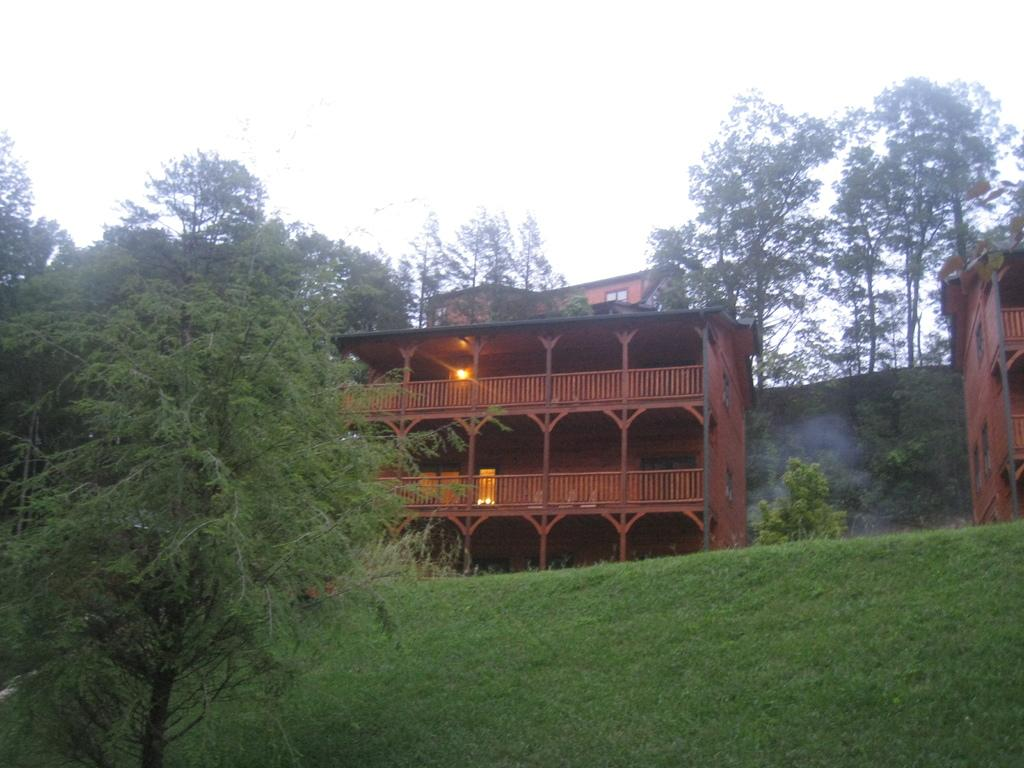What type of structures can be seen in the image? There are buildings in the image. What type of artificial light is visible in the image? Electric lights are visible in the image. What type of vegetation is present in the image? There are trees in the image. What type of geographical feature can be seen in the image? There are hills in the image. What part of the natural environment is visible in the image? The sky is visible in the image. What type of pain is being experienced by the trees in the image? There is no indication of pain in the image, as trees do not have the ability to experience pain. What type of need is being fulfilled by the buildings in the image? There is no indication of a specific need being fulfilled by the buildings in the image, as they are simply structures. 